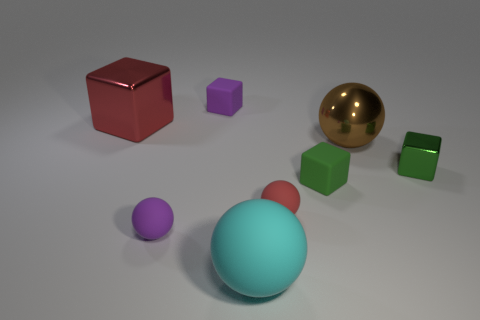What materials do the objects in the image seem to be made of? The objects in the image look like they're made from different materials: the sphere has a reflective surface suggesting it could be metal, the cubes and blocks might be made of a matte plastic or painted wood due to their solid colors and diffuse reflections. 